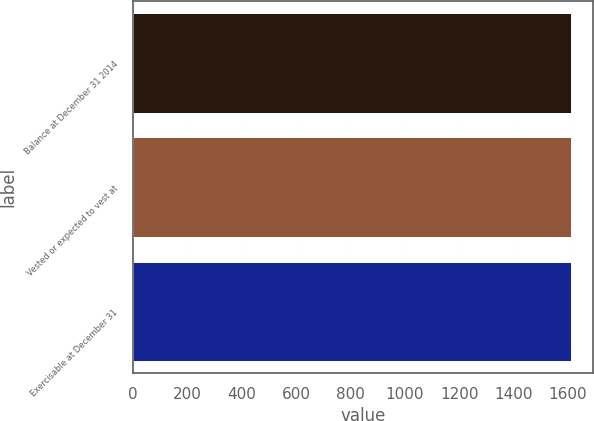<chart> <loc_0><loc_0><loc_500><loc_500><bar_chart><fcel>Balance at December 31 2014<fcel>Vested or expected to vest at<fcel>Exercisable at December 31<nl><fcel>1611<fcel>1611.1<fcel>1610<nl></chart> 